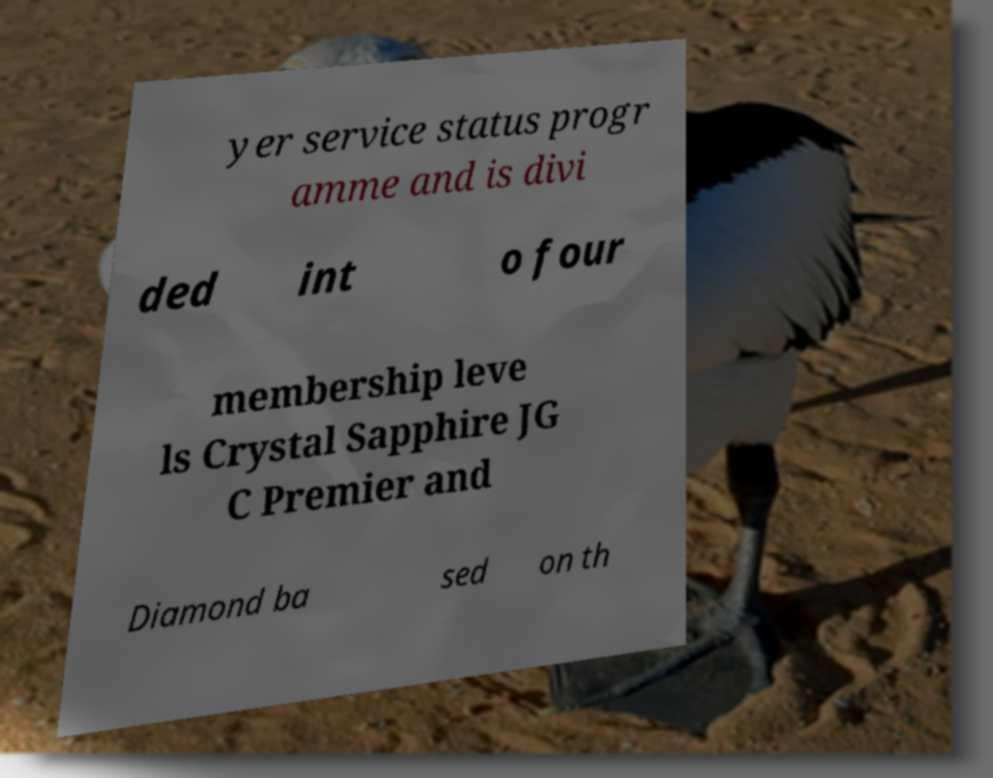Please identify and transcribe the text found in this image. yer service status progr amme and is divi ded int o four membership leve ls Crystal Sapphire JG C Premier and Diamond ba sed on th 